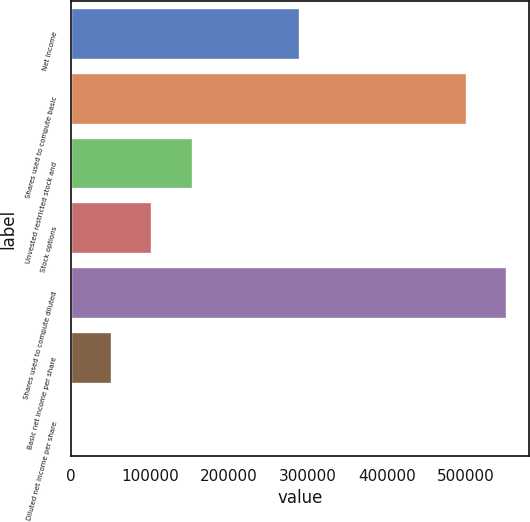Convert chart to OTSL. <chart><loc_0><loc_0><loc_500><loc_500><bar_chart><fcel>Net income<fcel>Shares used to compute basic<fcel>Unvested restricted stock and<fcel>Stock options<fcel>Shares used to compute diluted<fcel>Basic net income per share<fcel>Diluted net income per share<nl><fcel>289985<fcel>501372<fcel>154043<fcel>102696<fcel>552720<fcel>51348.1<fcel>0.56<nl></chart> 